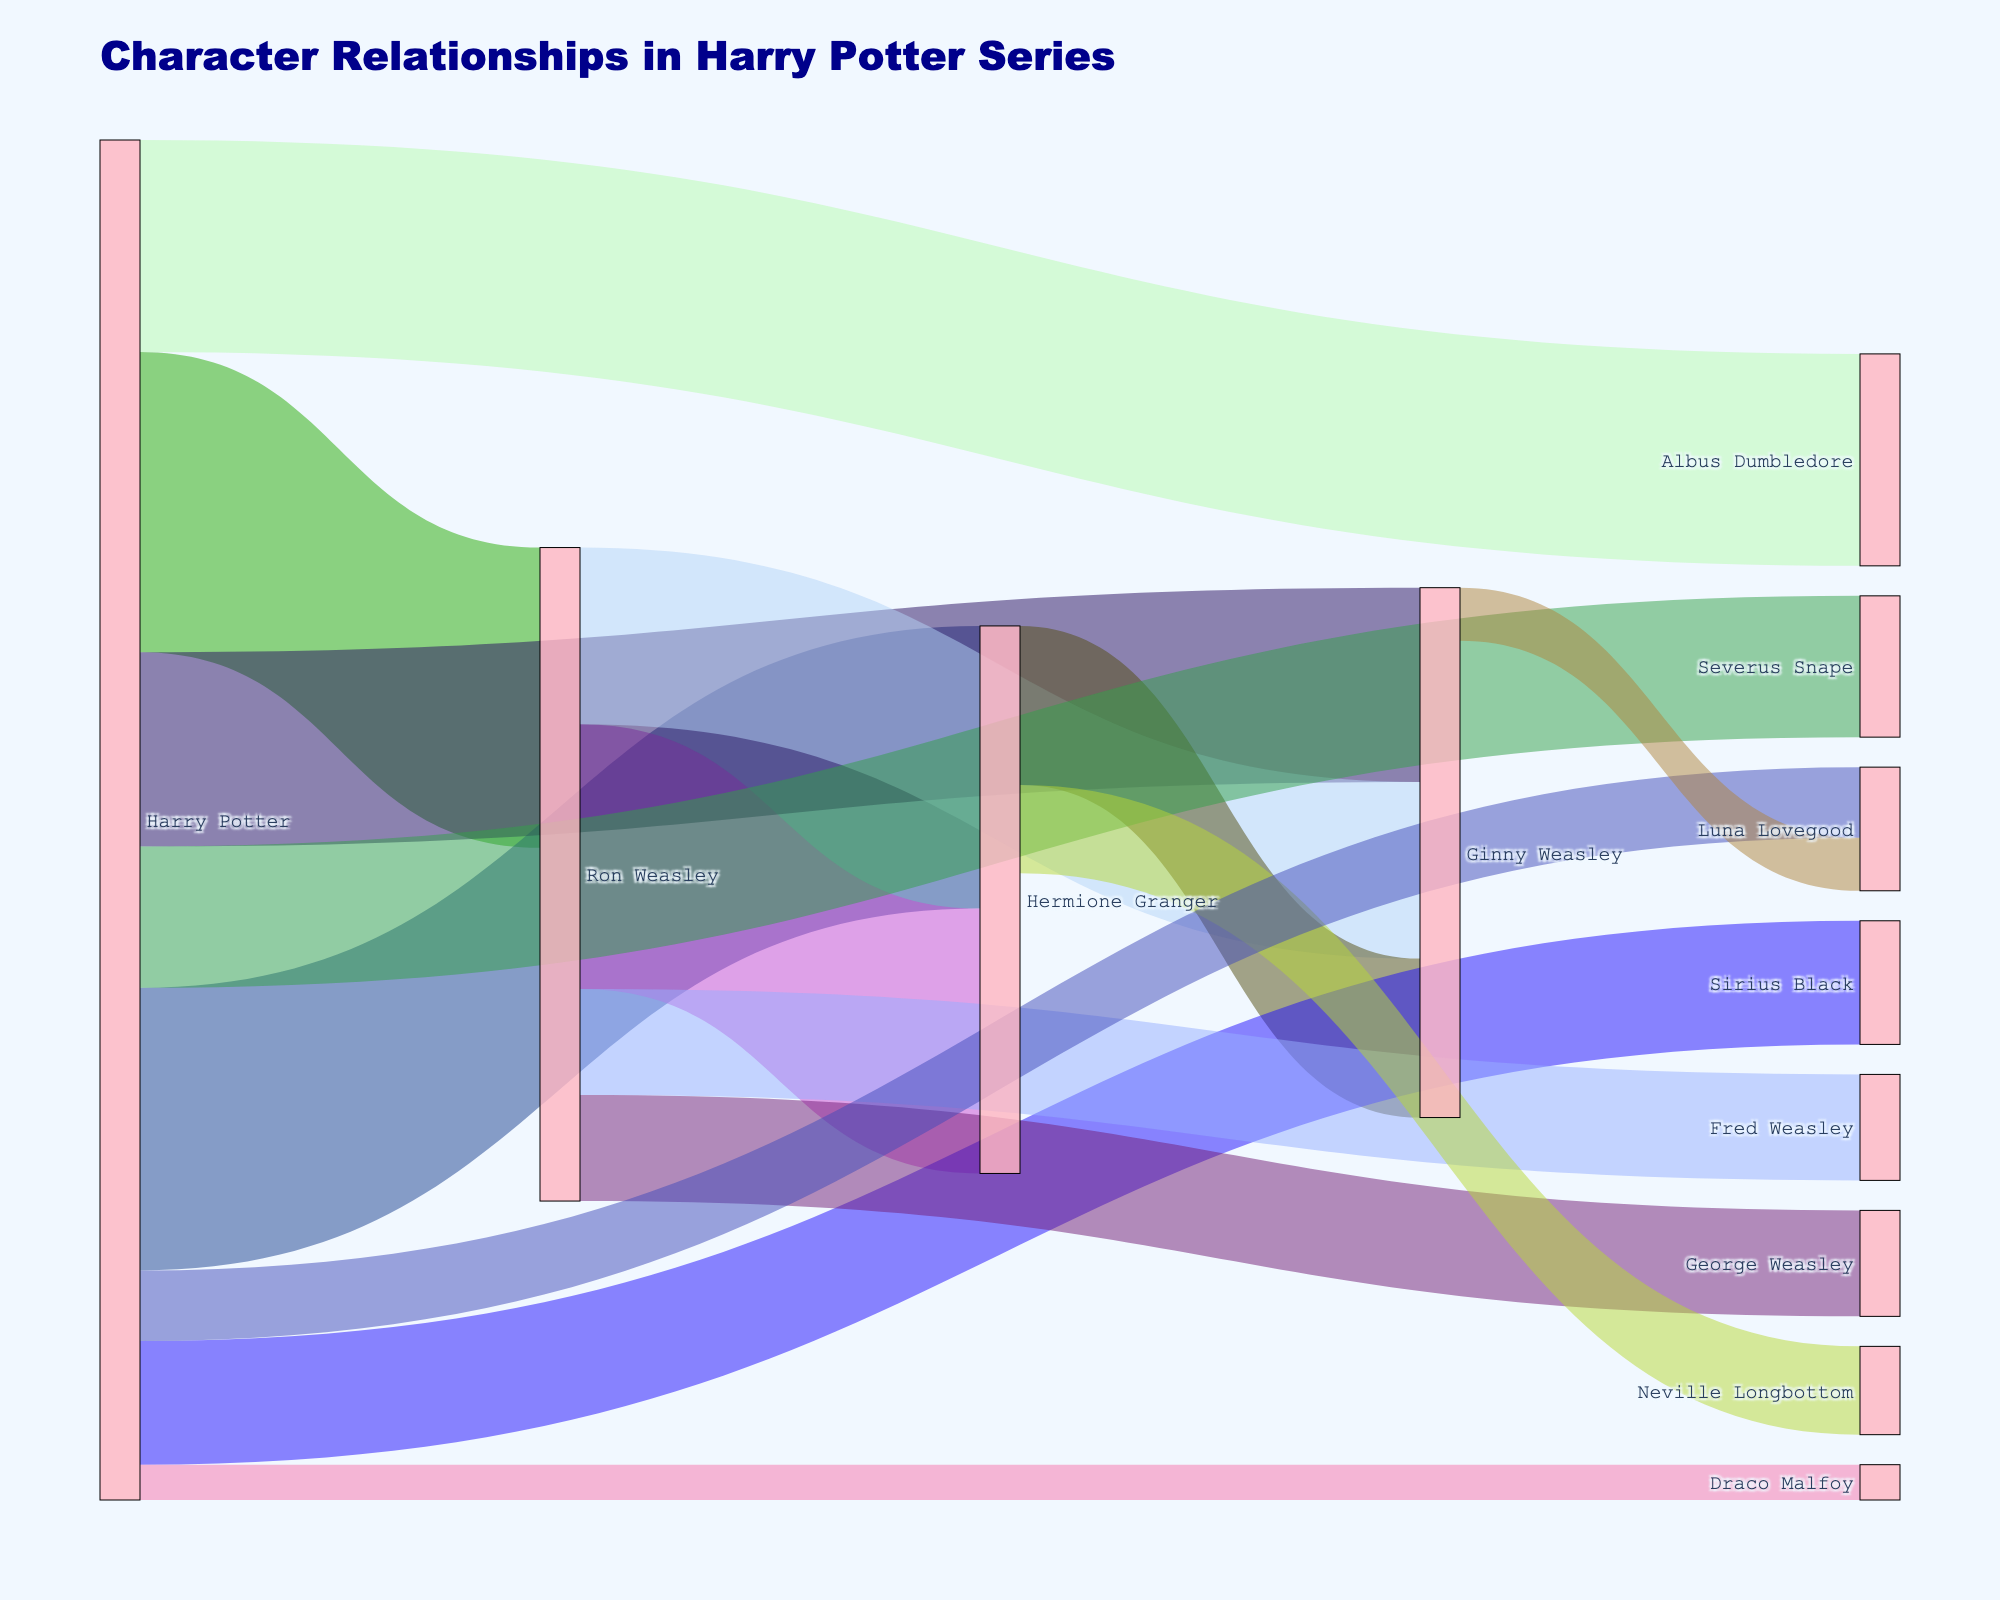How many nodes (characters) are there in the figure? Count the total number of unique characters labeled in the plot.
Answer: 11 Which character has the highest number of connections? Look for the character that appears most frequently among the sources and targets. Harry Potter is connected to the most characters.
Answer: Harry Potter What is the link value between Harry Potter and Ginny Weasley? Find the specific link between Harry Potter and Ginny Weasley and read the value.
Answer: 55 How many total links involve Hermione Granger? Add up all the link values where Hermione Granger is either the source or the target (80 + 75 + 45 + 25).
Answer: 225 Which characters are connected with the value of 30? Look for the link with the value of 30 and identify the characters involved (noting multiple connections of the same value).
Answer: Ron Weasley-Fred Weasley, Ron Weasley-George Weasley Who has the weakest connection with Harry Potter? Identify the link connected to Harry Potter with the lowest value.
Answer: Draco Malfoy What is the total value of interactions involving the Weasley siblings? Sum up all values involving Ron, Ginny, Fred, and George Weasley (85 + 50 + 30 + 30).
Answer: 195 Which character has a connection value of 45, and who are they connected with? Look for a link with the value of 45 and identify the characters involved. Hermione Granger has a link value of 45 with Ginny Weasley.
Answer: Hermione Granger and Ginny Weasley Which character interactions involve at least 3 different Weasleys? Find the characters that are connected directly to at least three of the Weasley family members (Harry Potter is connected with Ron, Ginny).
Answer: Harry Potter What character interaction has a value of 20, and which characters are involved? Identify the specific interaction and the characters connected with the value of 20.
Answer: Harry Potter and Luna Lovegood 